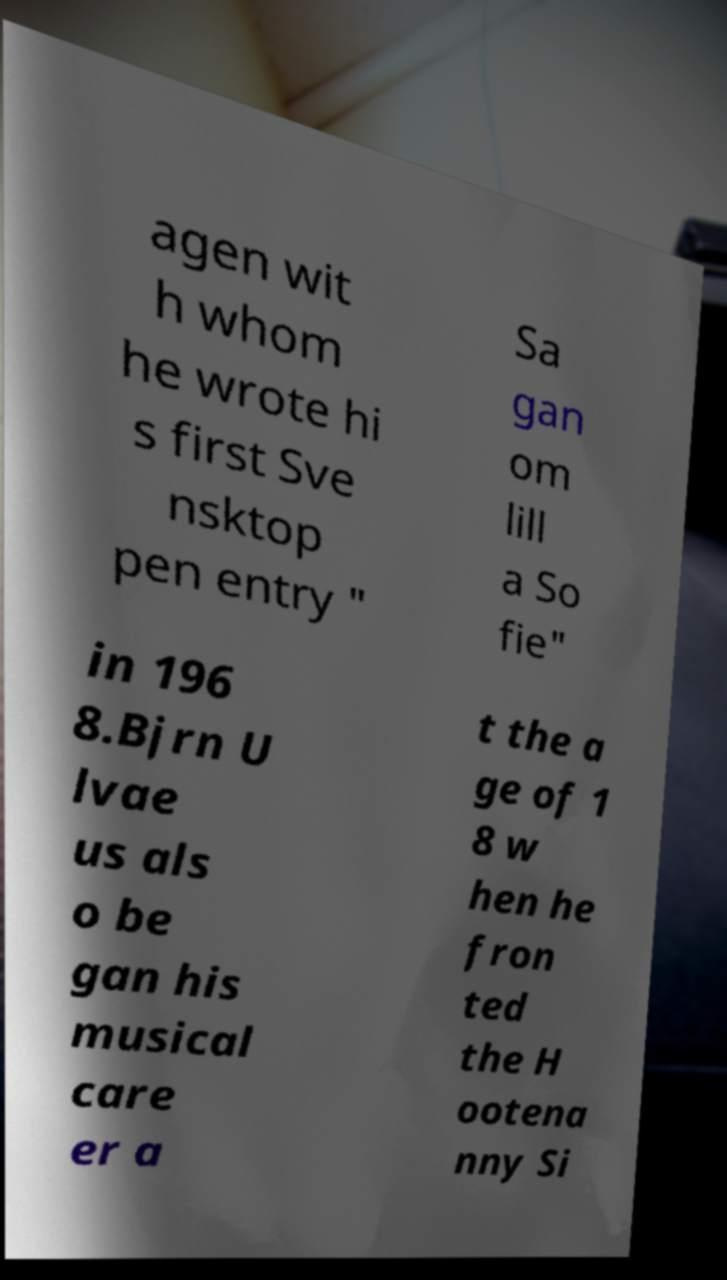I need the written content from this picture converted into text. Can you do that? agen wit h whom he wrote hi s first Sve nsktop pen entry " Sa gan om lill a So fie" in 196 8.Bjrn U lvae us als o be gan his musical care er a t the a ge of 1 8 w hen he fron ted the H ootena nny Si 